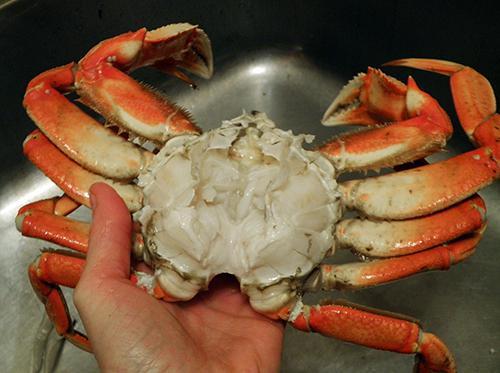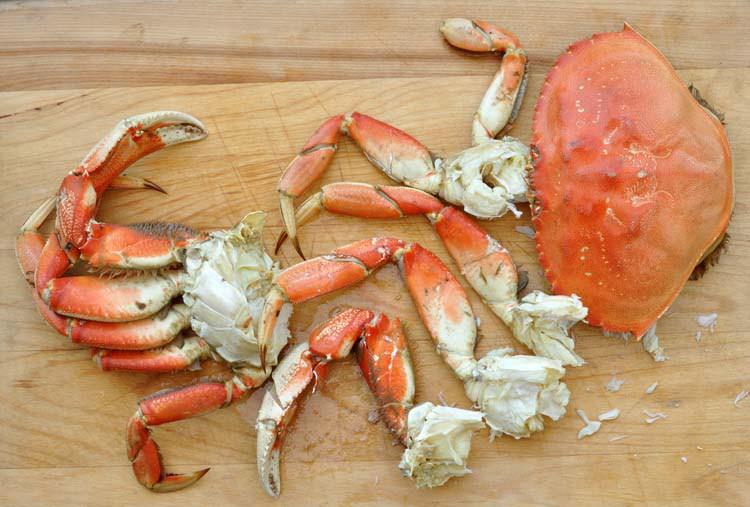The first image is the image on the left, the second image is the image on the right. Considering the images on both sides, is "A person is holding up the crab in the image on the left." valid? Answer yes or no. Yes. The first image is the image on the left, the second image is the image on the right. Examine the images to the left and right. Is the description "A hand is holding onto a crab in at least one image, and a crab is on a wooden board in the right image." accurate? Answer yes or no. Yes. 